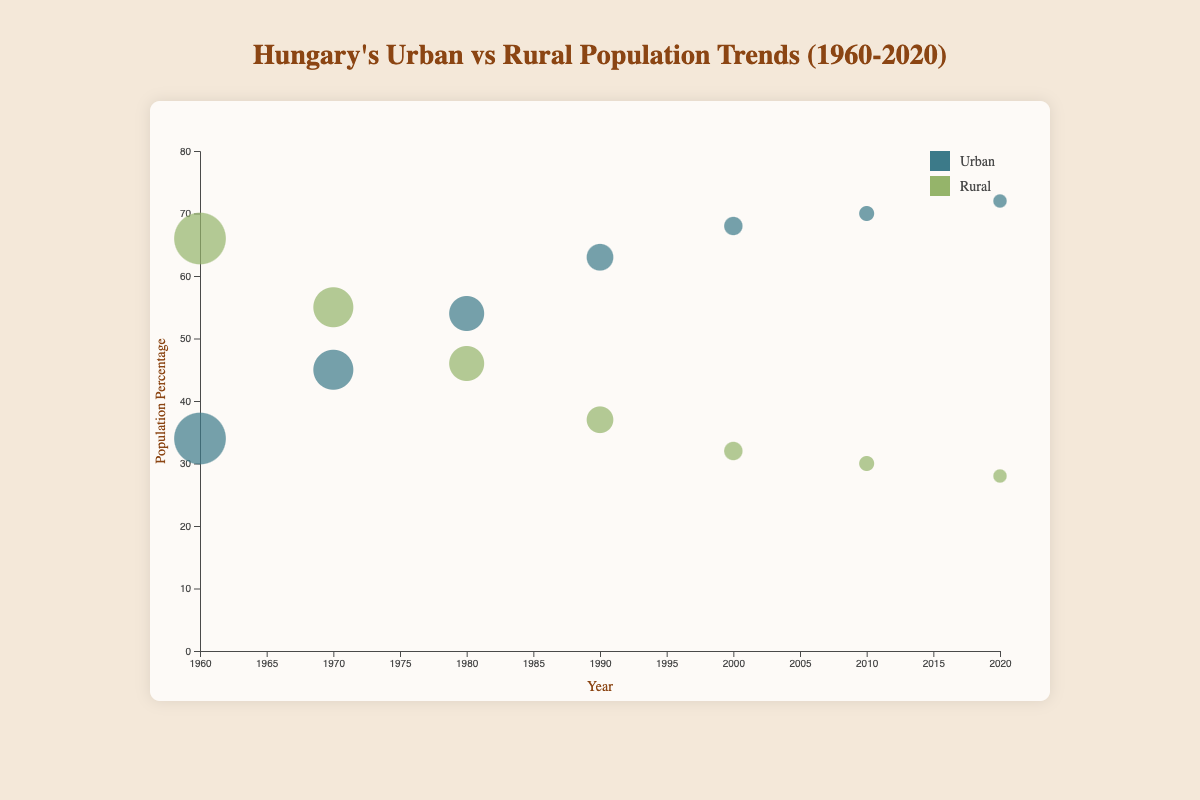What is the title of the chart? The chart's title is centered at the top and written in a distinctive color.
Answer: Hungary's Urban vs Rural Population Trends (1960-2020) How does the urban population percentage change from 1960 to 2020? By observing the vertical positions of the urban bubbles on the Y-axis from 1960 to 2020, the urban population increases from 34% to 72%.
Answer: Increases from 34% to 72% Which year had the highest urban migration rate? Looking at the size of the bubbles representing urban migration, the largest bubble is in 1960.
Answer: 1960 Compare the rural population percentages between 1980 and 2020. Which year had a higher percentage? By comparing the vertical positions of the rural bubbles in 1980 and 2020, 1980 has a higher percentage (46%) compared to 2020 (28%).
Answer: 1980 How has the size of urban migration bubbles changed over the years? Observing the sizes of the urban migration bubbles from 1960 to 2020, the size notably decreases from very large in 1960 to very small by 2020.
Answer: Decreased over the years What is the overall trend in rural migration rates from 1960 to 2020? The sizes of the rural migration rate bubbles get smaller over the years, indicating a decrease in migration rates.
Answer: Decreasing trend What color represents the urban population in the chart? The legend at the right side of the chart indicates that the urban population is represented in a blue-green color.
Answer: Blue-green What is the difference in the urban population percentage between 1970 and 1990? The urban population in 1970 is 45% and in 1990 is 63%. The difference is 63% - 45% = 18%.
Answer: 18% From 1960 to 2020, does the rural or urban population experience a greater absolute percentage change? The rural population drops from 66% to 28% (a change of 38%), while the urban population increases from 34% to 72% (a change of 38%). Both have the same absolute change.
Answer: Same (38%) Which decade saw the greatest decrease in rural migration rate? Comparing the bubble sizes for rural migration rates in each decade, the greatest decrease is from 1960 to 1970, where the migration rate falls from -2.5% to -1.8%.
Answer: 1960s What pattern can be observed for rural and urban population trends in Hungary based on the chart? The chart shows that the urban population increases while the rural population decreases, and the migration rates for both urban and rural areas decline over the years.
Answer: Urban grows, rural declines, and migration rates decrease 